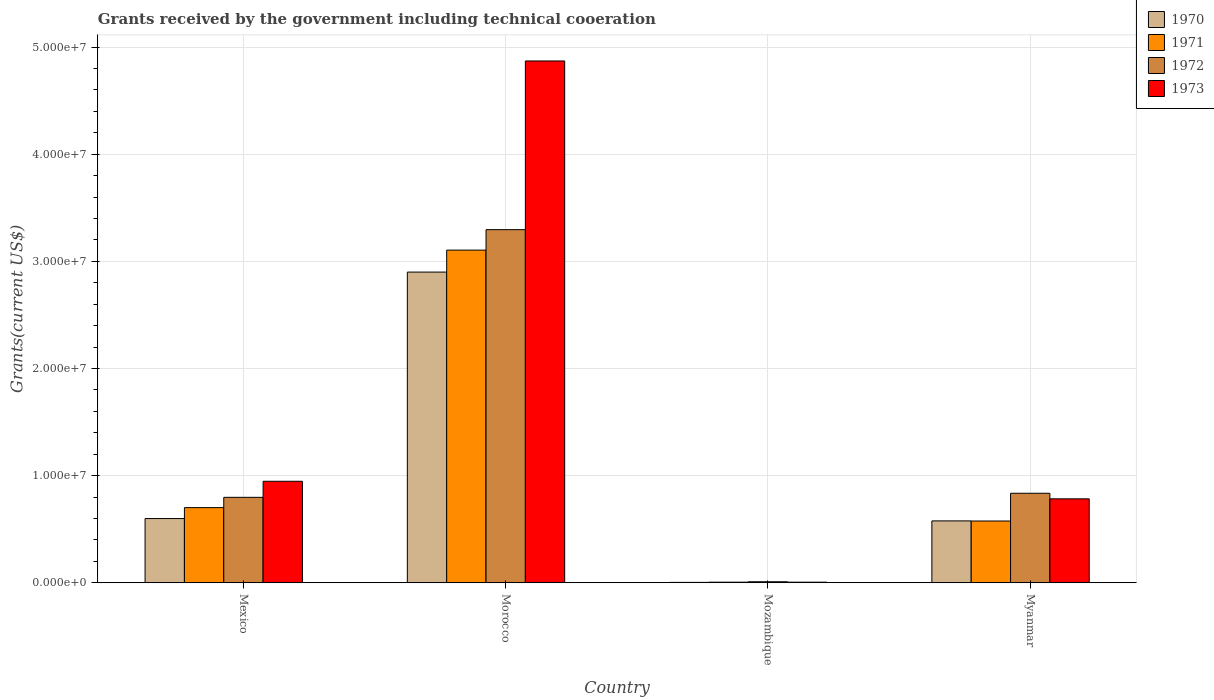How many different coloured bars are there?
Ensure brevity in your answer.  4. How many groups of bars are there?
Provide a short and direct response. 4. Are the number of bars on each tick of the X-axis equal?
Make the answer very short. Yes. How many bars are there on the 2nd tick from the left?
Offer a terse response. 4. How many bars are there on the 2nd tick from the right?
Offer a very short reply. 4. What is the label of the 3rd group of bars from the left?
Provide a short and direct response. Mozambique. In how many cases, is the number of bars for a given country not equal to the number of legend labels?
Provide a short and direct response. 0. What is the total grants received by the government in 1970 in Mexico?
Ensure brevity in your answer.  5.99e+06. Across all countries, what is the maximum total grants received by the government in 1971?
Offer a very short reply. 3.10e+07. Across all countries, what is the minimum total grants received by the government in 1970?
Provide a succinct answer. 3.00e+04. In which country was the total grants received by the government in 1971 maximum?
Offer a very short reply. Morocco. In which country was the total grants received by the government in 1973 minimum?
Offer a very short reply. Mozambique. What is the total total grants received by the government in 1972 in the graph?
Your answer should be compact. 4.94e+07. What is the difference between the total grants received by the government in 1972 in Mexico and that in Myanmar?
Give a very brief answer. -3.80e+05. What is the difference between the total grants received by the government in 1972 in Mexico and the total grants received by the government in 1971 in Morocco?
Provide a short and direct response. -2.31e+07. What is the average total grants received by the government in 1973 per country?
Provide a short and direct response. 1.65e+07. What is the difference between the total grants received by the government of/in 1973 and total grants received by the government of/in 1971 in Mexico?
Offer a very short reply. 2.46e+06. What is the ratio of the total grants received by the government in 1970 in Mexico to that in Mozambique?
Offer a very short reply. 199.67. Is the difference between the total grants received by the government in 1973 in Mexico and Myanmar greater than the difference between the total grants received by the government in 1971 in Mexico and Myanmar?
Provide a succinct answer. Yes. What is the difference between the highest and the second highest total grants received by the government in 1971?
Your response must be concise. 2.53e+07. What is the difference between the highest and the lowest total grants received by the government in 1973?
Your response must be concise. 4.87e+07. In how many countries, is the total grants received by the government in 1970 greater than the average total grants received by the government in 1970 taken over all countries?
Provide a succinct answer. 1. What does the 2nd bar from the left in Myanmar represents?
Provide a short and direct response. 1971. What does the 4th bar from the right in Morocco represents?
Keep it short and to the point. 1970. Is it the case that in every country, the sum of the total grants received by the government in 1970 and total grants received by the government in 1972 is greater than the total grants received by the government in 1973?
Provide a succinct answer. Yes. How many bars are there?
Your response must be concise. 16. What is the difference between two consecutive major ticks on the Y-axis?
Your answer should be compact. 1.00e+07. Are the values on the major ticks of Y-axis written in scientific E-notation?
Provide a short and direct response. Yes. Does the graph contain grids?
Your answer should be compact. Yes. Where does the legend appear in the graph?
Keep it short and to the point. Top right. What is the title of the graph?
Keep it short and to the point. Grants received by the government including technical cooeration. What is the label or title of the X-axis?
Offer a very short reply. Country. What is the label or title of the Y-axis?
Keep it short and to the point. Grants(current US$). What is the Grants(current US$) of 1970 in Mexico?
Your answer should be very brief. 5.99e+06. What is the Grants(current US$) of 1971 in Mexico?
Offer a terse response. 7.01e+06. What is the Grants(current US$) in 1972 in Mexico?
Give a very brief answer. 7.97e+06. What is the Grants(current US$) of 1973 in Mexico?
Ensure brevity in your answer.  9.47e+06. What is the Grants(current US$) of 1970 in Morocco?
Ensure brevity in your answer.  2.90e+07. What is the Grants(current US$) of 1971 in Morocco?
Provide a short and direct response. 3.10e+07. What is the Grants(current US$) in 1972 in Morocco?
Provide a succinct answer. 3.30e+07. What is the Grants(current US$) in 1973 in Morocco?
Provide a succinct answer. 4.87e+07. What is the Grants(current US$) in 1973 in Mozambique?
Ensure brevity in your answer.  5.00e+04. What is the Grants(current US$) of 1970 in Myanmar?
Provide a short and direct response. 5.77e+06. What is the Grants(current US$) in 1971 in Myanmar?
Provide a succinct answer. 5.76e+06. What is the Grants(current US$) in 1972 in Myanmar?
Offer a terse response. 8.35e+06. What is the Grants(current US$) in 1973 in Myanmar?
Your response must be concise. 7.83e+06. Across all countries, what is the maximum Grants(current US$) of 1970?
Your response must be concise. 2.90e+07. Across all countries, what is the maximum Grants(current US$) of 1971?
Ensure brevity in your answer.  3.10e+07. Across all countries, what is the maximum Grants(current US$) of 1972?
Provide a short and direct response. 3.30e+07. Across all countries, what is the maximum Grants(current US$) in 1973?
Give a very brief answer. 4.87e+07. Across all countries, what is the minimum Grants(current US$) in 1970?
Provide a short and direct response. 3.00e+04. Across all countries, what is the minimum Grants(current US$) of 1971?
Give a very brief answer. 5.00e+04. Across all countries, what is the minimum Grants(current US$) in 1973?
Offer a terse response. 5.00e+04. What is the total Grants(current US$) of 1970 in the graph?
Make the answer very short. 4.08e+07. What is the total Grants(current US$) of 1971 in the graph?
Offer a terse response. 4.39e+07. What is the total Grants(current US$) in 1972 in the graph?
Give a very brief answer. 4.94e+07. What is the total Grants(current US$) in 1973 in the graph?
Offer a very short reply. 6.61e+07. What is the difference between the Grants(current US$) of 1970 in Mexico and that in Morocco?
Your answer should be compact. -2.30e+07. What is the difference between the Grants(current US$) of 1971 in Mexico and that in Morocco?
Your answer should be compact. -2.40e+07. What is the difference between the Grants(current US$) in 1972 in Mexico and that in Morocco?
Make the answer very short. -2.50e+07. What is the difference between the Grants(current US$) in 1973 in Mexico and that in Morocco?
Your response must be concise. -3.92e+07. What is the difference between the Grants(current US$) in 1970 in Mexico and that in Mozambique?
Give a very brief answer. 5.96e+06. What is the difference between the Grants(current US$) of 1971 in Mexico and that in Mozambique?
Your response must be concise. 6.96e+06. What is the difference between the Grants(current US$) in 1972 in Mexico and that in Mozambique?
Ensure brevity in your answer.  7.88e+06. What is the difference between the Grants(current US$) of 1973 in Mexico and that in Mozambique?
Ensure brevity in your answer.  9.42e+06. What is the difference between the Grants(current US$) of 1971 in Mexico and that in Myanmar?
Your answer should be very brief. 1.25e+06. What is the difference between the Grants(current US$) in 1972 in Mexico and that in Myanmar?
Keep it short and to the point. -3.80e+05. What is the difference between the Grants(current US$) in 1973 in Mexico and that in Myanmar?
Offer a terse response. 1.64e+06. What is the difference between the Grants(current US$) of 1970 in Morocco and that in Mozambique?
Your answer should be very brief. 2.90e+07. What is the difference between the Grants(current US$) in 1971 in Morocco and that in Mozambique?
Offer a terse response. 3.10e+07. What is the difference between the Grants(current US$) of 1972 in Morocco and that in Mozambique?
Offer a very short reply. 3.29e+07. What is the difference between the Grants(current US$) in 1973 in Morocco and that in Mozambique?
Give a very brief answer. 4.87e+07. What is the difference between the Grants(current US$) of 1970 in Morocco and that in Myanmar?
Your answer should be compact. 2.32e+07. What is the difference between the Grants(current US$) of 1971 in Morocco and that in Myanmar?
Offer a very short reply. 2.53e+07. What is the difference between the Grants(current US$) in 1972 in Morocco and that in Myanmar?
Ensure brevity in your answer.  2.46e+07. What is the difference between the Grants(current US$) in 1973 in Morocco and that in Myanmar?
Make the answer very short. 4.09e+07. What is the difference between the Grants(current US$) of 1970 in Mozambique and that in Myanmar?
Your answer should be very brief. -5.74e+06. What is the difference between the Grants(current US$) of 1971 in Mozambique and that in Myanmar?
Provide a short and direct response. -5.71e+06. What is the difference between the Grants(current US$) of 1972 in Mozambique and that in Myanmar?
Give a very brief answer. -8.26e+06. What is the difference between the Grants(current US$) of 1973 in Mozambique and that in Myanmar?
Give a very brief answer. -7.78e+06. What is the difference between the Grants(current US$) of 1970 in Mexico and the Grants(current US$) of 1971 in Morocco?
Offer a terse response. -2.51e+07. What is the difference between the Grants(current US$) in 1970 in Mexico and the Grants(current US$) in 1972 in Morocco?
Offer a very short reply. -2.70e+07. What is the difference between the Grants(current US$) in 1970 in Mexico and the Grants(current US$) in 1973 in Morocco?
Ensure brevity in your answer.  -4.27e+07. What is the difference between the Grants(current US$) of 1971 in Mexico and the Grants(current US$) of 1972 in Morocco?
Offer a terse response. -2.60e+07. What is the difference between the Grants(current US$) of 1971 in Mexico and the Grants(current US$) of 1973 in Morocco?
Offer a very short reply. -4.17e+07. What is the difference between the Grants(current US$) in 1972 in Mexico and the Grants(current US$) in 1973 in Morocco?
Your response must be concise. -4.07e+07. What is the difference between the Grants(current US$) in 1970 in Mexico and the Grants(current US$) in 1971 in Mozambique?
Your answer should be compact. 5.94e+06. What is the difference between the Grants(current US$) in 1970 in Mexico and the Grants(current US$) in 1972 in Mozambique?
Offer a terse response. 5.90e+06. What is the difference between the Grants(current US$) of 1970 in Mexico and the Grants(current US$) of 1973 in Mozambique?
Ensure brevity in your answer.  5.94e+06. What is the difference between the Grants(current US$) of 1971 in Mexico and the Grants(current US$) of 1972 in Mozambique?
Offer a terse response. 6.92e+06. What is the difference between the Grants(current US$) in 1971 in Mexico and the Grants(current US$) in 1973 in Mozambique?
Ensure brevity in your answer.  6.96e+06. What is the difference between the Grants(current US$) in 1972 in Mexico and the Grants(current US$) in 1973 in Mozambique?
Offer a terse response. 7.92e+06. What is the difference between the Grants(current US$) in 1970 in Mexico and the Grants(current US$) in 1971 in Myanmar?
Provide a succinct answer. 2.30e+05. What is the difference between the Grants(current US$) of 1970 in Mexico and the Grants(current US$) of 1972 in Myanmar?
Ensure brevity in your answer.  -2.36e+06. What is the difference between the Grants(current US$) of 1970 in Mexico and the Grants(current US$) of 1973 in Myanmar?
Provide a short and direct response. -1.84e+06. What is the difference between the Grants(current US$) in 1971 in Mexico and the Grants(current US$) in 1972 in Myanmar?
Make the answer very short. -1.34e+06. What is the difference between the Grants(current US$) of 1971 in Mexico and the Grants(current US$) of 1973 in Myanmar?
Provide a short and direct response. -8.20e+05. What is the difference between the Grants(current US$) of 1970 in Morocco and the Grants(current US$) of 1971 in Mozambique?
Provide a short and direct response. 2.90e+07. What is the difference between the Grants(current US$) in 1970 in Morocco and the Grants(current US$) in 1972 in Mozambique?
Keep it short and to the point. 2.89e+07. What is the difference between the Grants(current US$) of 1970 in Morocco and the Grants(current US$) of 1973 in Mozambique?
Keep it short and to the point. 2.90e+07. What is the difference between the Grants(current US$) in 1971 in Morocco and the Grants(current US$) in 1972 in Mozambique?
Your answer should be compact. 3.10e+07. What is the difference between the Grants(current US$) in 1971 in Morocco and the Grants(current US$) in 1973 in Mozambique?
Offer a terse response. 3.10e+07. What is the difference between the Grants(current US$) of 1972 in Morocco and the Grants(current US$) of 1973 in Mozambique?
Provide a short and direct response. 3.29e+07. What is the difference between the Grants(current US$) in 1970 in Morocco and the Grants(current US$) in 1971 in Myanmar?
Ensure brevity in your answer.  2.32e+07. What is the difference between the Grants(current US$) of 1970 in Morocco and the Grants(current US$) of 1972 in Myanmar?
Provide a short and direct response. 2.06e+07. What is the difference between the Grants(current US$) of 1970 in Morocco and the Grants(current US$) of 1973 in Myanmar?
Ensure brevity in your answer.  2.12e+07. What is the difference between the Grants(current US$) in 1971 in Morocco and the Grants(current US$) in 1972 in Myanmar?
Provide a short and direct response. 2.27e+07. What is the difference between the Grants(current US$) of 1971 in Morocco and the Grants(current US$) of 1973 in Myanmar?
Provide a short and direct response. 2.32e+07. What is the difference between the Grants(current US$) in 1972 in Morocco and the Grants(current US$) in 1973 in Myanmar?
Your answer should be compact. 2.51e+07. What is the difference between the Grants(current US$) in 1970 in Mozambique and the Grants(current US$) in 1971 in Myanmar?
Offer a very short reply. -5.73e+06. What is the difference between the Grants(current US$) of 1970 in Mozambique and the Grants(current US$) of 1972 in Myanmar?
Your answer should be compact. -8.32e+06. What is the difference between the Grants(current US$) in 1970 in Mozambique and the Grants(current US$) in 1973 in Myanmar?
Ensure brevity in your answer.  -7.80e+06. What is the difference between the Grants(current US$) of 1971 in Mozambique and the Grants(current US$) of 1972 in Myanmar?
Give a very brief answer. -8.30e+06. What is the difference between the Grants(current US$) in 1971 in Mozambique and the Grants(current US$) in 1973 in Myanmar?
Your answer should be compact. -7.78e+06. What is the difference between the Grants(current US$) of 1972 in Mozambique and the Grants(current US$) of 1973 in Myanmar?
Your answer should be compact. -7.74e+06. What is the average Grants(current US$) in 1970 per country?
Your answer should be very brief. 1.02e+07. What is the average Grants(current US$) in 1971 per country?
Provide a short and direct response. 1.10e+07. What is the average Grants(current US$) in 1972 per country?
Provide a short and direct response. 1.23e+07. What is the average Grants(current US$) in 1973 per country?
Keep it short and to the point. 1.65e+07. What is the difference between the Grants(current US$) of 1970 and Grants(current US$) of 1971 in Mexico?
Keep it short and to the point. -1.02e+06. What is the difference between the Grants(current US$) in 1970 and Grants(current US$) in 1972 in Mexico?
Keep it short and to the point. -1.98e+06. What is the difference between the Grants(current US$) in 1970 and Grants(current US$) in 1973 in Mexico?
Your answer should be compact. -3.48e+06. What is the difference between the Grants(current US$) in 1971 and Grants(current US$) in 1972 in Mexico?
Offer a very short reply. -9.60e+05. What is the difference between the Grants(current US$) in 1971 and Grants(current US$) in 1973 in Mexico?
Your response must be concise. -2.46e+06. What is the difference between the Grants(current US$) in 1972 and Grants(current US$) in 1973 in Mexico?
Your response must be concise. -1.50e+06. What is the difference between the Grants(current US$) in 1970 and Grants(current US$) in 1971 in Morocco?
Offer a very short reply. -2.05e+06. What is the difference between the Grants(current US$) of 1970 and Grants(current US$) of 1972 in Morocco?
Offer a very short reply. -3.96e+06. What is the difference between the Grants(current US$) in 1970 and Grants(current US$) in 1973 in Morocco?
Offer a very short reply. -1.97e+07. What is the difference between the Grants(current US$) in 1971 and Grants(current US$) in 1972 in Morocco?
Make the answer very short. -1.91e+06. What is the difference between the Grants(current US$) of 1971 and Grants(current US$) of 1973 in Morocco?
Make the answer very short. -1.77e+07. What is the difference between the Grants(current US$) in 1972 and Grants(current US$) in 1973 in Morocco?
Your answer should be compact. -1.58e+07. What is the difference between the Grants(current US$) in 1970 and Grants(current US$) in 1973 in Mozambique?
Offer a terse response. -2.00e+04. What is the difference between the Grants(current US$) of 1971 and Grants(current US$) of 1972 in Mozambique?
Your answer should be very brief. -4.00e+04. What is the difference between the Grants(current US$) of 1970 and Grants(current US$) of 1972 in Myanmar?
Provide a succinct answer. -2.58e+06. What is the difference between the Grants(current US$) of 1970 and Grants(current US$) of 1973 in Myanmar?
Offer a very short reply. -2.06e+06. What is the difference between the Grants(current US$) in 1971 and Grants(current US$) in 1972 in Myanmar?
Provide a succinct answer. -2.59e+06. What is the difference between the Grants(current US$) of 1971 and Grants(current US$) of 1973 in Myanmar?
Provide a succinct answer. -2.07e+06. What is the difference between the Grants(current US$) of 1972 and Grants(current US$) of 1973 in Myanmar?
Keep it short and to the point. 5.20e+05. What is the ratio of the Grants(current US$) in 1970 in Mexico to that in Morocco?
Provide a succinct answer. 0.21. What is the ratio of the Grants(current US$) in 1971 in Mexico to that in Morocco?
Your answer should be compact. 0.23. What is the ratio of the Grants(current US$) in 1972 in Mexico to that in Morocco?
Keep it short and to the point. 0.24. What is the ratio of the Grants(current US$) in 1973 in Mexico to that in Morocco?
Provide a succinct answer. 0.19. What is the ratio of the Grants(current US$) in 1970 in Mexico to that in Mozambique?
Your response must be concise. 199.67. What is the ratio of the Grants(current US$) of 1971 in Mexico to that in Mozambique?
Ensure brevity in your answer.  140.2. What is the ratio of the Grants(current US$) in 1972 in Mexico to that in Mozambique?
Your answer should be compact. 88.56. What is the ratio of the Grants(current US$) of 1973 in Mexico to that in Mozambique?
Your answer should be compact. 189.4. What is the ratio of the Grants(current US$) of 1970 in Mexico to that in Myanmar?
Offer a terse response. 1.04. What is the ratio of the Grants(current US$) of 1971 in Mexico to that in Myanmar?
Give a very brief answer. 1.22. What is the ratio of the Grants(current US$) of 1972 in Mexico to that in Myanmar?
Your answer should be very brief. 0.95. What is the ratio of the Grants(current US$) in 1973 in Mexico to that in Myanmar?
Your answer should be compact. 1.21. What is the ratio of the Grants(current US$) of 1970 in Morocco to that in Mozambique?
Ensure brevity in your answer.  966.67. What is the ratio of the Grants(current US$) in 1971 in Morocco to that in Mozambique?
Give a very brief answer. 621. What is the ratio of the Grants(current US$) of 1972 in Morocco to that in Mozambique?
Keep it short and to the point. 366.22. What is the ratio of the Grants(current US$) of 1973 in Morocco to that in Mozambique?
Provide a short and direct response. 974.2. What is the ratio of the Grants(current US$) of 1970 in Morocco to that in Myanmar?
Your answer should be compact. 5.03. What is the ratio of the Grants(current US$) in 1971 in Morocco to that in Myanmar?
Provide a succinct answer. 5.39. What is the ratio of the Grants(current US$) of 1972 in Morocco to that in Myanmar?
Offer a very short reply. 3.95. What is the ratio of the Grants(current US$) in 1973 in Morocco to that in Myanmar?
Give a very brief answer. 6.22. What is the ratio of the Grants(current US$) of 1970 in Mozambique to that in Myanmar?
Offer a terse response. 0.01. What is the ratio of the Grants(current US$) in 1971 in Mozambique to that in Myanmar?
Offer a very short reply. 0.01. What is the ratio of the Grants(current US$) of 1972 in Mozambique to that in Myanmar?
Provide a succinct answer. 0.01. What is the ratio of the Grants(current US$) in 1973 in Mozambique to that in Myanmar?
Offer a very short reply. 0.01. What is the difference between the highest and the second highest Grants(current US$) in 1970?
Make the answer very short. 2.30e+07. What is the difference between the highest and the second highest Grants(current US$) of 1971?
Make the answer very short. 2.40e+07. What is the difference between the highest and the second highest Grants(current US$) in 1972?
Keep it short and to the point. 2.46e+07. What is the difference between the highest and the second highest Grants(current US$) of 1973?
Provide a short and direct response. 3.92e+07. What is the difference between the highest and the lowest Grants(current US$) of 1970?
Give a very brief answer. 2.90e+07. What is the difference between the highest and the lowest Grants(current US$) in 1971?
Your answer should be compact. 3.10e+07. What is the difference between the highest and the lowest Grants(current US$) of 1972?
Provide a succinct answer. 3.29e+07. What is the difference between the highest and the lowest Grants(current US$) of 1973?
Ensure brevity in your answer.  4.87e+07. 